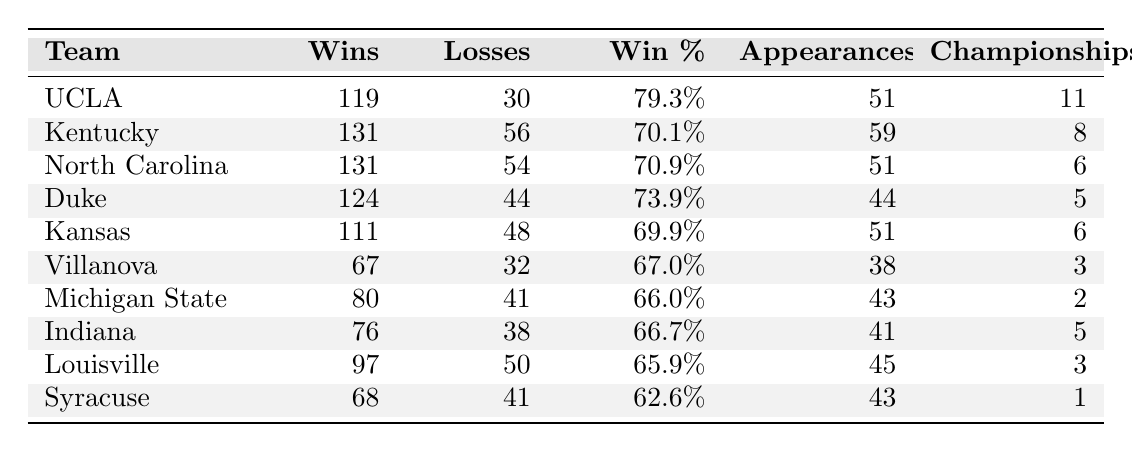What team has the highest number of tournament wins? UCLA has the highest number of tournament wins, with a total of 119.
Answer: UCLA What is the win percentage of Kentucky? Kentucky has a win percentage of 70.1%.
Answer: 70.1% Which team has the lowest number of championships won? Syracuse has won the fewest championships, with a total of 1 championship.
Answer: Syracuse How many total championships have the top three teams won? The top three teams are UCLA (11), Kentucky (8), and North Carolina (6). Adding these together gives 11 + 8 + 6 = 25 championships.
Answer: 25 Which team has a better win-loss record: Kansas or Indiana? Kansas has 111 wins and 48 losses, giving a win percentage of 69.9%. Indiana has 76 wins and 38 losses, giving a win percentage of 66.7%. Kansas has the better record.
Answer: Kansas How many teams have a win percentage over 70%? The teams with a win percentage over 70% are UCLA (79.3%), North Carolina (70.9%), and Kentucky (70.1%). Thus, there are three teams.
Answer: 3 Which two teams have the same number of wins? Kentucky and North Carolina both have 131 wins each.
Answer: Kentucky and North Carolina What is the average number of tournament appearances for the teams listed? The total number of appearances is 51 + 59 + 51 + 44 + 51 + 38 + 43 + 41 + 45 + 43 = 422. There are 10 teams, so the average is 422 / 10 = 42.2.
Answer: 42.2 Is it true that Michigan State has more losses than wins? Michigan State has 80 wins and 41 losses, which indicates they have more wins than losses. Thus, the statement is false.
Answer: No Which team has the fewest tournament appearances? Villanova has the fewest tournament appearances, with a total of 38.
Answer: Villanova 